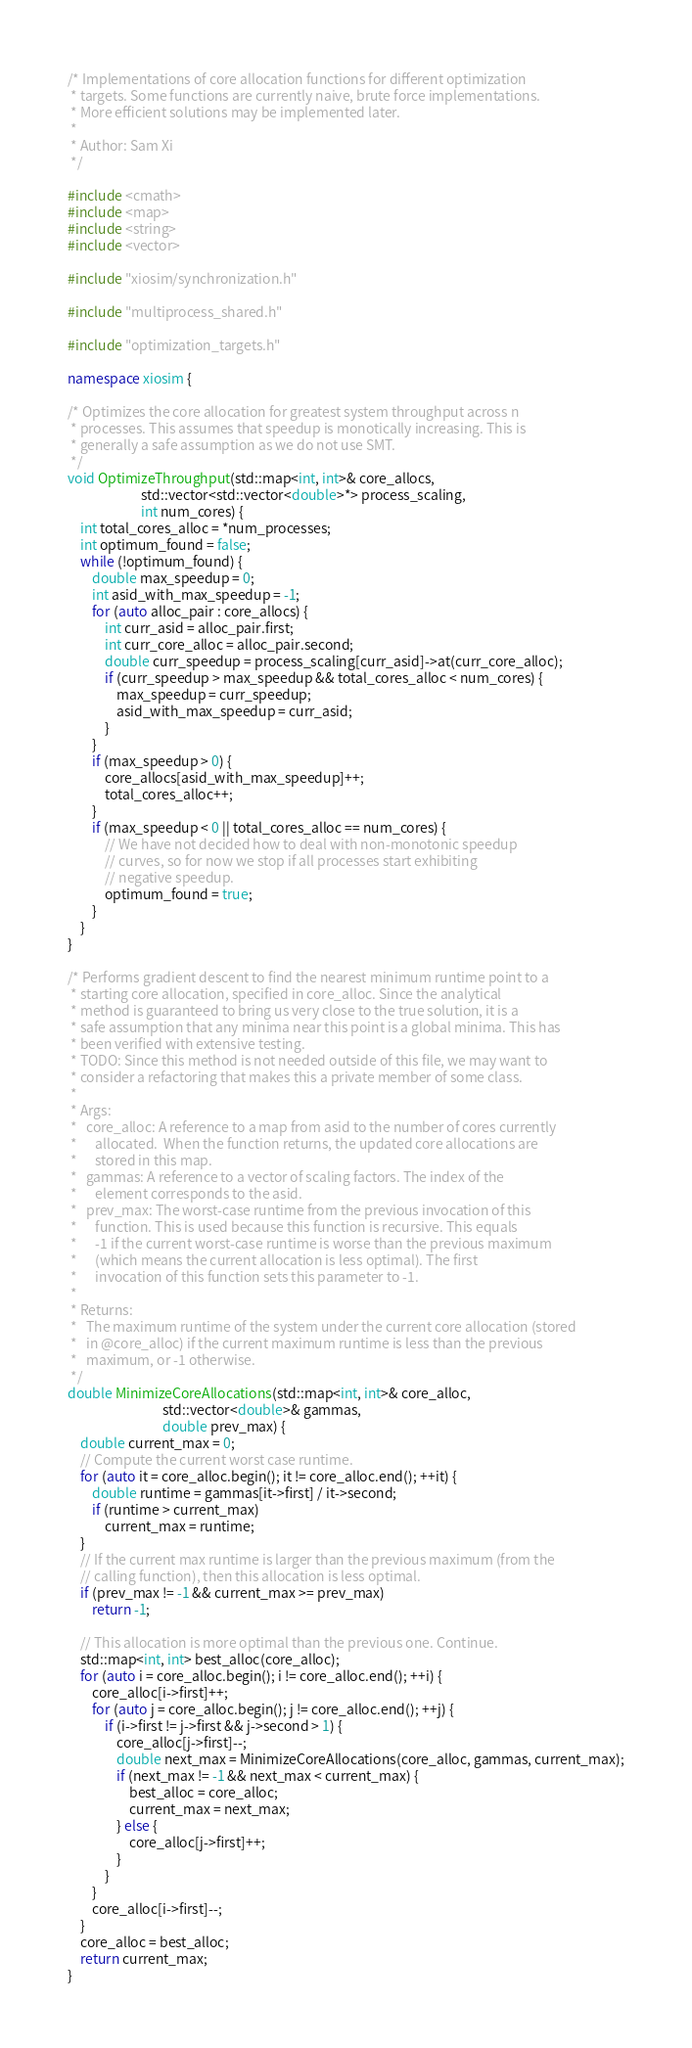<code> <loc_0><loc_0><loc_500><loc_500><_C++_>/* Implementations of core allocation functions for different optimization
 * targets. Some functions are currently naive, brute force implementations.
 * More efficient solutions may be implemented later.
 *
 * Author: Sam Xi
 */

#include <cmath>
#include <map>
#include <string>
#include <vector>

#include "xiosim/synchronization.h"

#include "multiprocess_shared.h"

#include "optimization_targets.h"

namespace xiosim {

/* Optimizes the core allocation for greatest system throughput across n
 * processes. This assumes that speedup is monotically increasing. This is
 * generally a safe assumption as we do not use SMT.
 */
void OptimizeThroughput(std::map<int, int>& core_allocs,
                        std::vector<std::vector<double>*> process_scaling,
                        int num_cores) {
    int total_cores_alloc = *num_processes;
    int optimum_found = false;
    while (!optimum_found) {
        double max_speedup = 0;
        int asid_with_max_speedup = -1;
        for (auto alloc_pair : core_allocs) {
            int curr_asid = alloc_pair.first;
            int curr_core_alloc = alloc_pair.second;
            double curr_speedup = process_scaling[curr_asid]->at(curr_core_alloc);
            if (curr_speedup > max_speedup && total_cores_alloc < num_cores) {
                max_speedup = curr_speedup;
                asid_with_max_speedup = curr_asid;
            }
        }
        if (max_speedup > 0) {
            core_allocs[asid_with_max_speedup]++;
            total_cores_alloc++;
        }
        if (max_speedup < 0 || total_cores_alloc == num_cores) {
            // We have not decided how to deal with non-monotonic speedup
            // curves, so for now we stop if all processes start exhibiting
            // negative speedup.
            optimum_found = true;
        }
    }
}

/* Performs gradient descent to find the nearest minimum runtime point to a
 * starting core allocation, specified in core_alloc. Since the analytical
 * method is guaranteed to bring us very close to the true solution, it is a
 * safe assumption that any minima near this point is a global minima. This has
 * been verified with extensive testing.
 * TODO: Since this method is not needed outside of this file, we may want to
 * consider a refactoring that makes this a private member of some class.
 *
 * Args:
 *   core_alloc: A reference to a map from asid to the number of cores currently
 *      allocated.  When the function returns, the updated core allocations are
 *      stored in this map.
 *   gammas: A reference to a vector of scaling factors. The index of the
 *      element corresponds to the asid.
 *   prev_max: The worst-case runtime from the previous invocation of this
 *      function. This is used because this function is recursive. This equals
 *      -1 if the current worst-case runtime is worse than the previous maximum
 *      (which means the current allocation is less optimal). The first
 *      invocation of this function sets this parameter to -1.
 *
 * Returns:
 *   The maximum runtime of the system under the current core allocation (stored
 *   in @core_alloc) if the current maximum runtime is less than the previous
 *   maximum, or -1 otherwise.
 */
double MinimizeCoreAllocations(std::map<int, int>& core_alloc,
                               std::vector<double>& gammas,
                               double prev_max) {
    double current_max = 0;
    // Compute the current worst case runtime.
    for (auto it = core_alloc.begin(); it != core_alloc.end(); ++it) {
        double runtime = gammas[it->first] / it->second;
        if (runtime > current_max)
            current_max = runtime;
    }
    // If the current max runtime is larger than the previous maximum (from the
    // calling function), then this allocation is less optimal.
    if (prev_max != -1 && current_max >= prev_max)
        return -1;

    // This allocation is more optimal than the previous one. Continue.
    std::map<int, int> best_alloc(core_alloc);
    for (auto i = core_alloc.begin(); i != core_alloc.end(); ++i) {
        core_alloc[i->first]++;
        for (auto j = core_alloc.begin(); j != core_alloc.end(); ++j) {
            if (i->first != j->first && j->second > 1) {
                core_alloc[j->first]--;
                double next_max = MinimizeCoreAllocations(core_alloc, gammas, current_max);
                if (next_max != -1 && next_max < current_max) {
                    best_alloc = core_alloc;
                    current_max = next_max;
                } else {
                    core_alloc[j->first]++;
                }
            }
        }
        core_alloc[i->first]--;
    }
    core_alloc = best_alloc;
    return current_max;
}
</code> 